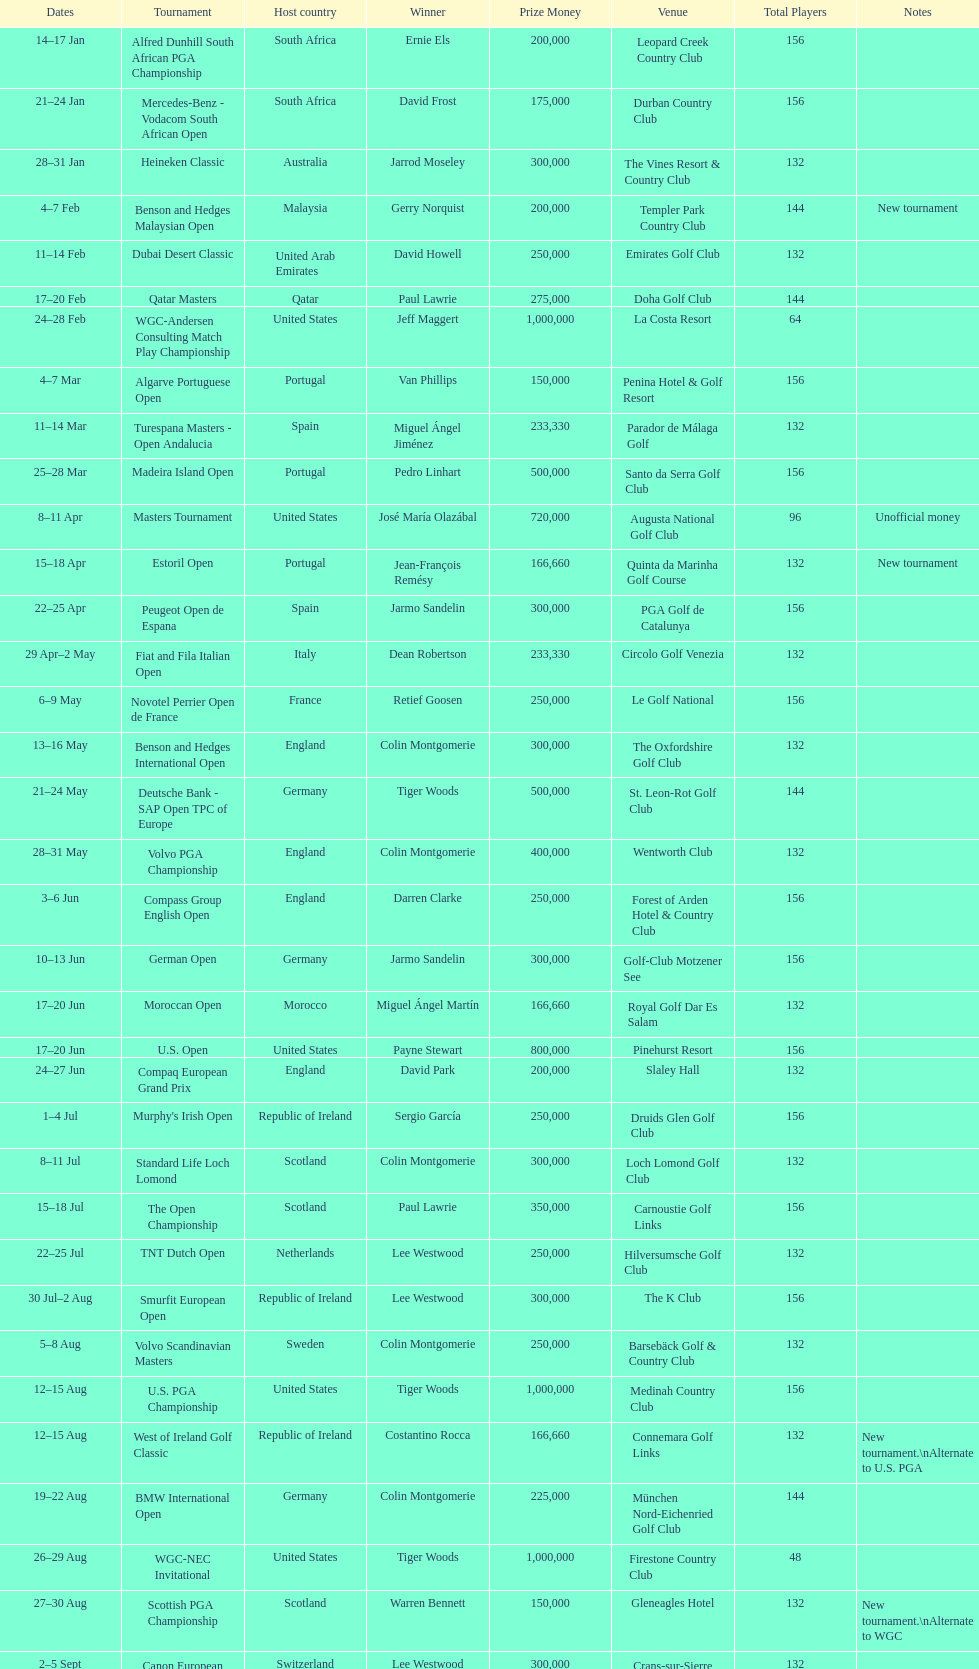Parse the full table. {'header': ['Dates', 'Tournament', 'Host country', 'Winner', 'Prize Money', 'Venue', 'Total Players', 'Notes'], 'rows': [['14–17\xa0Jan', 'Alfred Dunhill South African PGA Championship', 'South Africa', 'Ernie Els', '200,000', 'Leopard Creek Country Club', '156', ''], ['21–24\xa0Jan', 'Mercedes-Benz - Vodacom South African Open', 'South Africa', 'David Frost', '175,000', 'Durban Country Club', '156', ''], ['28–31\xa0Jan', 'Heineken Classic', 'Australia', 'Jarrod Moseley', '300,000', 'The Vines Resort & Country Club', '132', ''], ['4–7\xa0Feb', 'Benson and Hedges Malaysian Open', 'Malaysia', 'Gerry Norquist', '200,000', 'Templer Park Country Club', '144', 'New tournament'], ['11–14\xa0Feb', 'Dubai Desert Classic', 'United Arab Emirates', 'David Howell', '250,000', 'Emirates Golf Club', '132', ''], ['17–20\xa0Feb', 'Qatar Masters', 'Qatar', 'Paul Lawrie', '275,000', 'Doha Golf Club', '144', ''], ['24–28\xa0Feb', 'WGC-Andersen Consulting Match Play Championship', 'United States', 'Jeff Maggert', '1,000,000', 'La Costa Resort', '64', ''], ['4–7\xa0Mar', 'Algarve Portuguese Open', 'Portugal', 'Van Phillips', '150,000', 'Penina Hotel & Golf Resort', '156', ''], ['11–14\xa0Mar', 'Turespana Masters - Open Andalucia', 'Spain', 'Miguel Ángel Jiménez', '233,330', 'Parador de Málaga Golf', '132', ''], ['25–28\xa0Mar', 'Madeira Island Open', 'Portugal', 'Pedro Linhart', '500,000', 'Santo da Serra Golf Club', '156', ''], ['8–11\xa0Apr', 'Masters Tournament', 'United States', 'José María Olazábal', '720,000', 'Augusta National Golf Club', '96', 'Unofficial money'], ['15–18\xa0Apr', 'Estoril Open', 'Portugal', 'Jean-François Remésy', '166,660', 'Quinta da Marinha Golf Course', '132', 'New tournament'], ['22–25\xa0Apr', 'Peugeot Open de Espana', 'Spain', 'Jarmo Sandelin', '300,000', 'PGA Golf de Catalunya', '156', ''], ['29\xa0Apr–2\xa0May', 'Fiat and Fila Italian Open', 'Italy', 'Dean Robertson', '233,330', 'Circolo Golf Venezia', '132', ''], ['6–9\xa0May', 'Novotel Perrier Open de France', 'France', 'Retief Goosen', '250,000', 'Le Golf National', '156', ''], ['13–16\xa0May', 'Benson and Hedges International Open', 'England', 'Colin Montgomerie', '300,000', 'The Oxfordshire Golf Club', '132', ''], ['21–24\xa0May', 'Deutsche Bank - SAP Open TPC of Europe', 'Germany', 'Tiger Woods', '500,000', 'St. Leon-Rot Golf Club', '144', ''], ['28–31\xa0May', 'Volvo PGA Championship', 'England', 'Colin Montgomerie', '400,000', 'Wentworth Club', '132', ''], ['3–6\xa0Jun', 'Compass Group English Open', 'England', 'Darren Clarke', '250,000', 'Forest of Arden Hotel & Country Club', '156', ''], ['10–13\xa0Jun', 'German Open', 'Germany', 'Jarmo Sandelin', '300,000', 'Golf-Club Motzener See', '156', ''], ['17–20\xa0Jun', 'Moroccan Open', 'Morocco', 'Miguel Ángel Martín', '166,660', 'Royal Golf Dar Es Salam', '132', ''], ['17–20\xa0Jun', 'U.S. Open', 'United States', 'Payne Stewart', '800,000', 'Pinehurst Resort', '156', ''], ['24–27\xa0Jun', 'Compaq European Grand Prix', 'England', 'David Park', '200,000', 'Slaley Hall', '132', ''], ['1–4\xa0Jul', "Murphy's Irish Open", 'Republic of Ireland', 'Sergio García', '250,000', 'Druids Glen Golf Club', '156', ''], ['8–11\xa0Jul', 'Standard Life Loch Lomond', 'Scotland', 'Colin Montgomerie', '300,000', 'Loch Lomond Golf Club', '132', ''], ['15–18\xa0Jul', 'The Open Championship', 'Scotland', 'Paul Lawrie', '350,000', 'Carnoustie Golf Links', '156', ''], ['22–25\xa0Jul', 'TNT Dutch Open', 'Netherlands', 'Lee Westwood', '250,000', 'Hilversumsche Golf Club', '132', ''], ['30\xa0Jul–2\xa0Aug', 'Smurfit European Open', 'Republic of Ireland', 'Lee Westwood', '300,000', 'The K Club', '156', ''], ['5–8\xa0Aug', 'Volvo Scandinavian Masters', 'Sweden', 'Colin Montgomerie', '250,000', 'Barsebäck Golf & Country Club', '132', ''], ['12–15\xa0Aug', 'U.S. PGA Championship', 'United States', 'Tiger Woods', '1,000,000', 'Medinah Country Club', '156', ''], ['12–15\xa0Aug', 'West of Ireland Golf Classic', 'Republic of Ireland', 'Costantino Rocca', '166,660', 'Connemara Golf Links', '132', 'New tournament.\\nAlternate to U.S. PGA'], ['19–22\xa0Aug', 'BMW International Open', 'Germany', 'Colin Montgomerie', '225,000', 'München Nord-Eichenried Golf Club', '144', ''], ['26–29\xa0Aug', 'WGC-NEC Invitational', 'United States', 'Tiger Woods', '1,000,000', 'Firestone Country Club', '48', ''], ['27–30\xa0Aug', 'Scottish PGA Championship', 'Scotland', 'Warren Bennett', '150,000', 'Gleneagles Hotel', '132', 'New tournament.\\nAlternate to WGC'], ['2–5\xa0Sept', 'Canon European Masters', 'Switzerland', 'Lee Westwood', '300,000', 'Crans-sur-Sierre Golf Club', '132', ''], ['9–12\xa0Sept', 'Victor Chandler British Masters', 'England', 'Bob May', '250,000', 'Woburn Golf Club', '156', ''], ['16–19\xa0Sept', 'Trophée Lancôme', 'France', 'Pierre Fulke', '180,000', 'Saint-Nom-la-Bretèche Golf Course', '144', ''], ['24–27\xa0Sept', 'Ryder Cup', 'United States', 'United States', '-', 'The Country Club', '24', 'Team event'], ['30\xa0Sept–3\xa0Oct', 'Linde German Masters', 'Germany', 'Sergio García', '400,000', 'Gut Kaden Golf Club', '132', ''], ['7–10\xa0Oct', 'Alfred Dunhill Cup', 'Scotland', 'Spain', '-', 'St. Andrews Links', '48', 'Team event.\\nUnofficial money'], ['14–17\xa0Oct', 'Cisco World Match Play Championship', 'England', 'Colin Montgomerie', '250,000', 'Wentworth Club', '12', 'Unofficial money'], ['14–17\xa0Oct', 'Sarazen World Open', 'Spain', 'Thomas Bjørn', '250,000', 'Golf de Pals', '132', 'New tournament'], ['21–24\xa0Oct', 'Belgacom Open', 'Belgium', 'Robert Karlsson', '166,660', 'Royal Zoute Golf Club', '132', ''], ['28–31\xa0Oct', 'Volvo Masters', 'Spain', 'Miguel Ángel Jiménez', '400,000', 'Montecastillo Golf & Sports Resort', '72', ''], ['4–7\xa0Nov', 'WGC-American Express Championship', 'Spain', 'Tiger Woods', '1,000,000', 'Valderrama Golf Club', '72', ''], ['18–21\xa0Nov', 'World Cup of Golf', 'Malaysia', 'United States', '-', 'Mines Resort & Golf Club', '48', 'Team event.\\nUnofficial money']]} How many competitions started before august 15th? 31. 